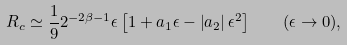Convert formula to latex. <formula><loc_0><loc_0><loc_500><loc_500>R _ { c } \simeq \frac { 1 } { 9 } 2 ^ { - 2 \beta - 1 } \epsilon \left [ 1 + a _ { 1 } \epsilon - \left | a _ { 2 } \right | \epsilon ^ { 2 } \right ] \quad ( \epsilon \rightarrow 0 ) ,</formula> 